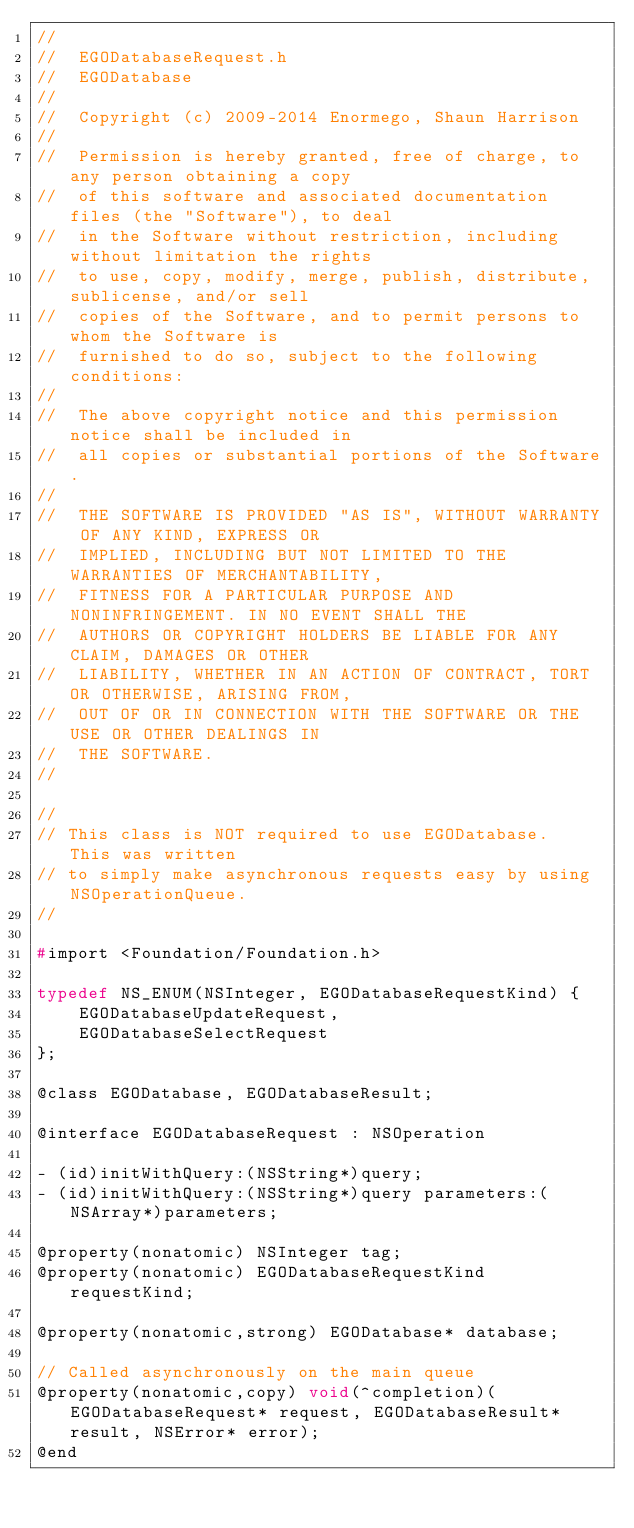<code> <loc_0><loc_0><loc_500><loc_500><_C_>//
//  EGODatabaseRequest.h
//  EGODatabase
//
//  Copyright (c) 2009-2014 Enormego, Shaun Harrison
//
//  Permission is hereby granted, free of charge, to any person obtaining a copy
//  of this software and associated documentation files (the "Software"), to deal
//  in the Software without restriction, including without limitation the rights
//  to use, copy, modify, merge, publish, distribute, sublicense, and/or sell
//  copies of the Software, and to permit persons to whom the Software is
//  furnished to do so, subject to the following conditions:
//
//  The above copyright notice and this permission notice shall be included in
//  all copies or substantial portions of the Software.
//
//  THE SOFTWARE IS PROVIDED "AS IS", WITHOUT WARRANTY OF ANY KIND, EXPRESS OR
//  IMPLIED, INCLUDING BUT NOT LIMITED TO THE WARRANTIES OF MERCHANTABILITY,
//  FITNESS FOR A PARTICULAR PURPOSE AND NONINFRINGEMENT. IN NO EVENT SHALL THE
//  AUTHORS OR COPYRIGHT HOLDERS BE LIABLE FOR ANY CLAIM, DAMAGES OR OTHER
//  LIABILITY, WHETHER IN AN ACTION OF CONTRACT, TORT OR OTHERWISE, ARISING FROM,
//  OUT OF OR IN CONNECTION WITH THE SOFTWARE OR THE USE OR OTHER DEALINGS IN
//  THE SOFTWARE.
//

//
// This class is NOT required to use EGODatabase.  This was written
// to simply make asynchronous requests easy by using NSOperationQueue.
//

#import <Foundation/Foundation.h>

typedef NS_ENUM(NSInteger, EGODatabaseRequestKind) {
	EGODatabaseUpdateRequest,
	EGODatabaseSelectRequest
};

@class EGODatabase, EGODatabaseResult;

@interface EGODatabaseRequest : NSOperation

- (id)initWithQuery:(NSString*)query;
- (id)initWithQuery:(NSString*)query parameters:(NSArray*)parameters;

@property(nonatomic) NSInteger tag;
@property(nonatomic) EGODatabaseRequestKind requestKind;

@property(nonatomic,strong) EGODatabase* database;

// Called asynchronously on the main queue
@property(nonatomic,copy) void(^completion)(EGODatabaseRequest* request, EGODatabaseResult* result, NSError* error);
@end
</code> 